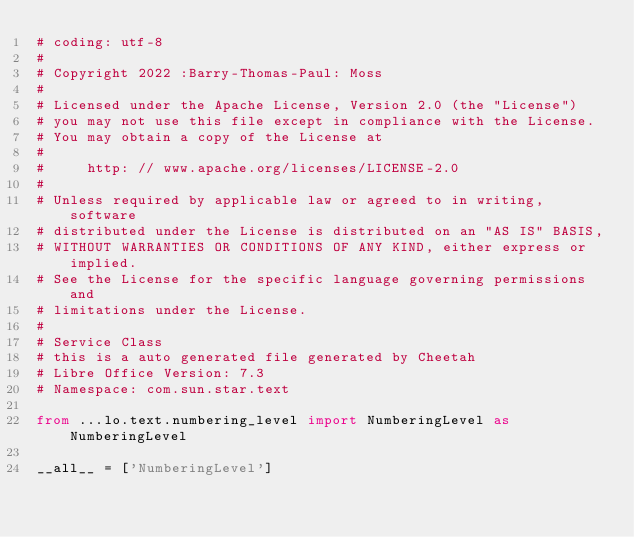<code> <loc_0><loc_0><loc_500><loc_500><_Python_># coding: utf-8
#
# Copyright 2022 :Barry-Thomas-Paul: Moss
#
# Licensed under the Apache License, Version 2.0 (the "License")
# you may not use this file except in compliance with the License.
# You may obtain a copy of the License at
#
#     http: // www.apache.org/licenses/LICENSE-2.0
#
# Unless required by applicable law or agreed to in writing, software
# distributed under the License is distributed on an "AS IS" BASIS,
# WITHOUT WARRANTIES OR CONDITIONS OF ANY KIND, either express or implied.
# See the License for the specific language governing permissions and
# limitations under the License.
#
# Service Class
# this is a auto generated file generated by Cheetah
# Libre Office Version: 7.3
# Namespace: com.sun.star.text

from ...lo.text.numbering_level import NumberingLevel as NumberingLevel

__all__ = ['NumberingLevel']

</code> 